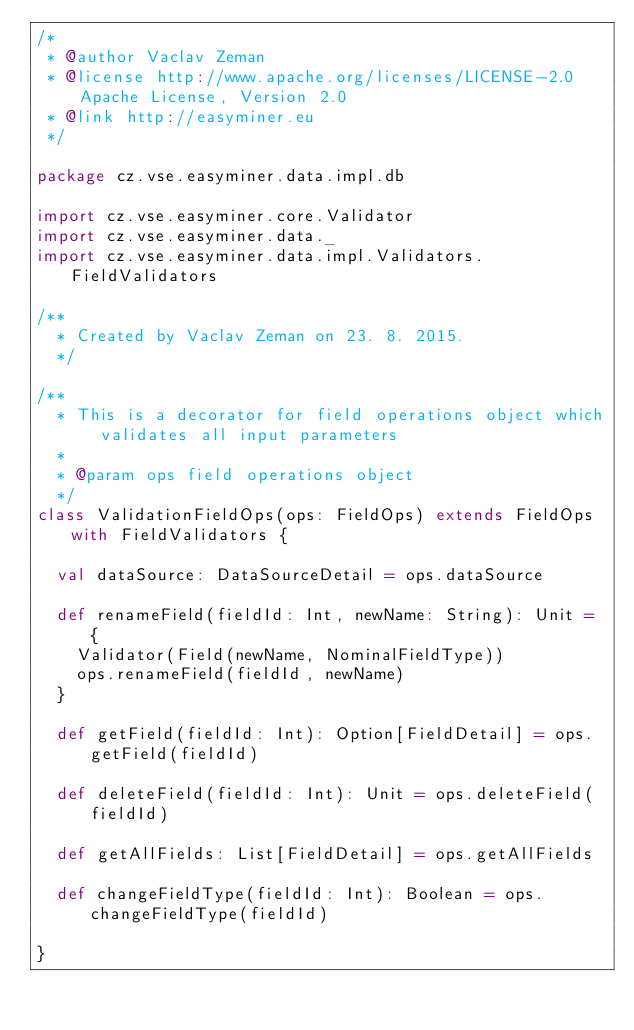<code> <loc_0><loc_0><loc_500><loc_500><_Scala_>/*
 * @author Vaclav Zeman
 * @license http://www.apache.org/licenses/LICENSE-2.0 Apache License, Version 2.0
 * @link http://easyminer.eu
 */

package cz.vse.easyminer.data.impl.db

import cz.vse.easyminer.core.Validator
import cz.vse.easyminer.data._
import cz.vse.easyminer.data.impl.Validators.FieldValidators

/**
  * Created by Vaclav Zeman on 23. 8. 2015.
  */

/**
  * This is a decorator for field operations object which validates all input parameters
  *
  * @param ops field operations object
  */
class ValidationFieldOps(ops: FieldOps) extends FieldOps with FieldValidators {

  val dataSource: DataSourceDetail = ops.dataSource

  def renameField(fieldId: Int, newName: String): Unit = {
    Validator(Field(newName, NominalFieldType))
    ops.renameField(fieldId, newName)
  }

  def getField(fieldId: Int): Option[FieldDetail] = ops.getField(fieldId)

  def deleteField(fieldId: Int): Unit = ops.deleteField(fieldId)

  def getAllFields: List[FieldDetail] = ops.getAllFields

  def changeFieldType(fieldId: Int): Boolean = ops.changeFieldType(fieldId)

}
</code> 